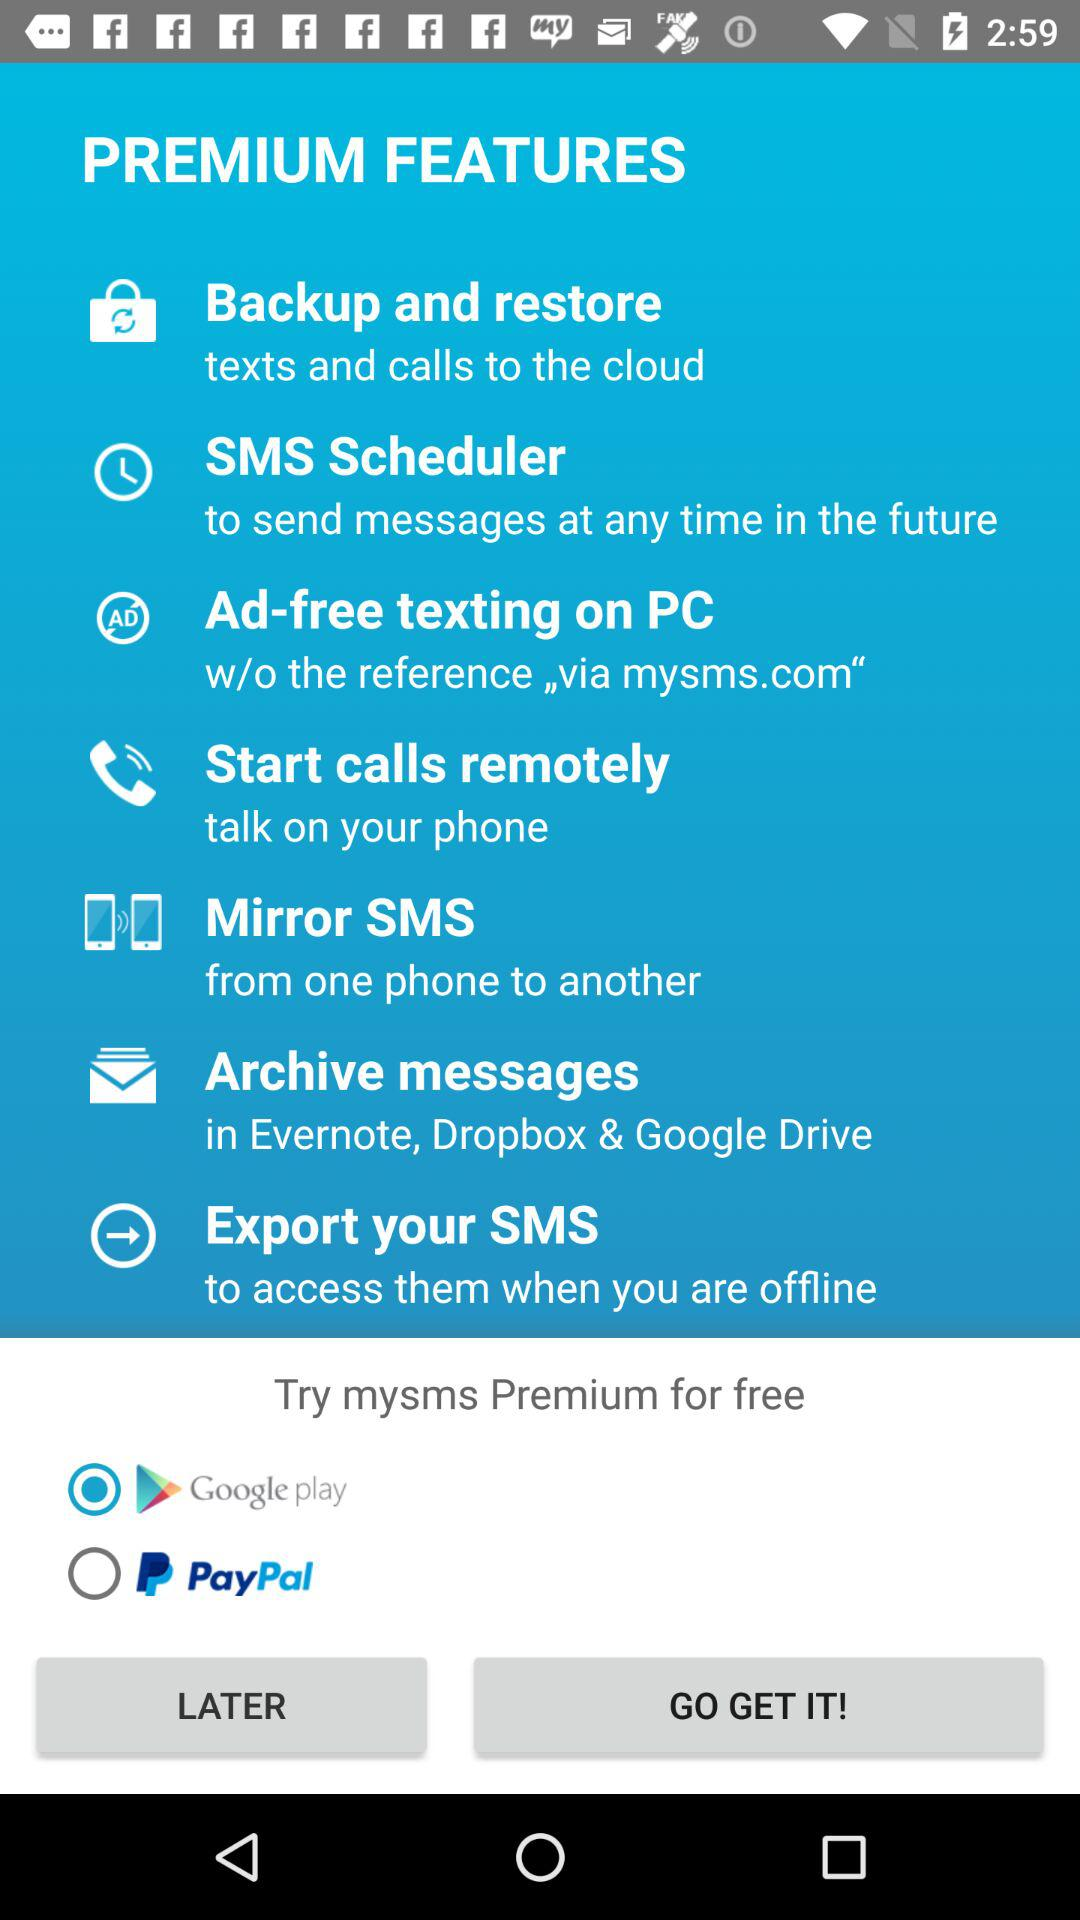What is the name of the application? The name of the application is "mysms". 